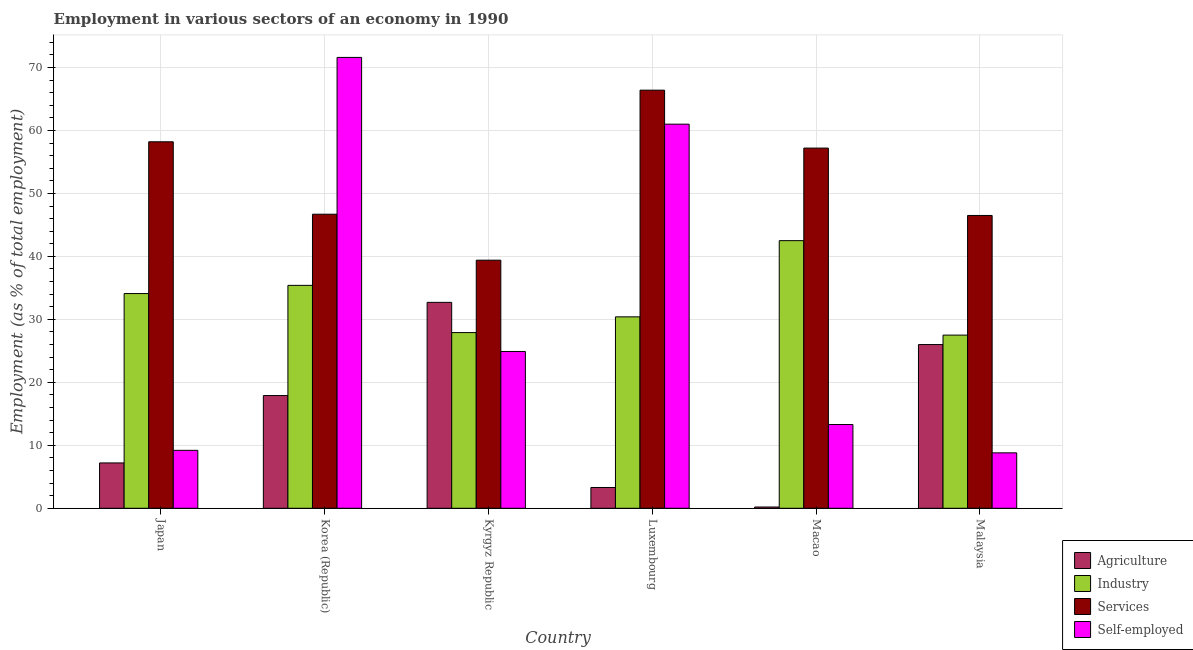How many different coloured bars are there?
Provide a short and direct response. 4. How many bars are there on the 6th tick from the right?
Offer a very short reply. 4. What is the label of the 6th group of bars from the left?
Offer a terse response. Malaysia. In how many cases, is the number of bars for a given country not equal to the number of legend labels?
Provide a succinct answer. 0. What is the percentage of workers in services in Kyrgyz Republic?
Keep it short and to the point. 39.4. Across all countries, what is the maximum percentage of self employed workers?
Make the answer very short. 71.6. Across all countries, what is the minimum percentage of self employed workers?
Your answer should be compact. 8.8. In which country was the percentage of workers in services maximum?
Your answer should be compact. Luxembourg. In which country was the percentage of workers in services minimum?
Give a very brief answer. Kyrgyz Republic. What is the total percentage of workers in industry in the graph?
Give a very brief answer. 197.8. What is the difference between the percentage of self employed workers in Macao and the percentage of workers in services in Kyrgyz Republic?
Your response must be concise. -26.1. What is the average percentage of workers in industry per country?
Make the answer very short. 32.97. What is the difference between the percentage of workers in industry and percentage of workers in agriculture in Malaysia?
Keep it short and to the point. 1.5. What is the ratio of the percentage of workers in services in Luxembourg to that in Malaysia?
Provide a succinct answer. 1.43. Is the difference between the percentage of workers in services in Korea (Republic) and Luxembourg greater than the difference between the percentage of self employed workers in Korea (Republic) and Luxembourg?
Offer a terse response. No. What is the difference between the highest and the second highest percentage of workers in industry?
Offer a very short reply. 7.1. What is the difference between the highest and the lowest percentage of workers in agriculture?
Offer a terse response. 32.5. In how many countries, is the percentage of self employed workers greater than the average percentage of self employed workers taken over all countries?
Offer a terse response. 2. What does the 1st bar from the left in Korea (Republic) represents?
Keep it short and to the point. Agriculture. What does the 2nd bar from the right in Japan represents?
Ensure brevity in your answer.  Services. Is it the case that in every country, the sum of the percentage of workers in agriculture and percentage of workers in industry is greater than the percentage of workers in services?
Your response must be concise. No. How many bars are there?
Give a very brief answer. 24. Are all the bars in the graph horizontal?
Give a very brief answer. No. Are the values on the major ticks of Y-axis written in scientific E-notation?
Keep it short and to the point. No. Does the graph contain grids?
Your answer should be compact. Yes. Where does the legend appear in the graph?
Your response must be concise. Bottom right. What is the title of the graph?
Your answer should be compact. Employment in various sectors of an economy in 1990. Does "Others" appear as one of the legend labels in the graph?
Offer a terse response. No. What is the label or title of the Y-axis?
Offer a very short reply. Employment (as % of total employment). What is the Employment (as % of total employment) in Agriculture in Japan?
Keep it short and to the point. 7.2. What is the Employment (as % of total employment) of Industry in Japan?
Your response must be concise. 34.1. What is the Employment (as % of total employment) of Services in Japan?
Make the answer very short. 58.2. What is the Employment (as % of total employment) of Self-employed in Japan?
Your answer should be compact. 9.2. What is the Employment (as % of total employment) in Agriculture in Korea (Republic)?
Ensure brevity in your answer.  17.9. What is the Employment (as % of total employment) of Industry in Korea (Republic)?
Offer a terse response. 35.4. What is the Employment (as % of total employment) in Services in Korea (Republic)?
Keep it short and to the point. 46.7. What is the Employment (as % of total employment) of Self-employed in Korea (Republic)?
Your response must be concise. 71.6. What is the Employment (as % of total employment) in Agriculture in Kyrgyz Republic?
Keep it short and to the point. 32.7. What is the Employment (as % of total employment) in Industry in Kyrgyz Republic?
Provide a short and direct response. 27.9. What is the Employment (as % of total employment) in Services in Kyrgyz Republic?
Your response must be concise. 39.4. What is the Employment (as % of total employment) in Self-employed in Kyrgyz Republic?
Your answer should be compact. 24.9. What is the Employment (as % of total employment) in Agriculture in Luxembourg?
Your response must be concise. 3.3. What is the Employment (as % of total employment) of Industry in Luxembourg?
Provide a succinct answer. 30.4. What is the Employment (as % of total employment) in Services in Luxembourg?
Keep it short and to the point. 66.4. What is the Employment (as % of total employment) in Agriculture in Macao?
Ensure brevity in your answer.  0.2. What is the Employment (as % of total employment) in Industry in Macao?
Provide a succinct answer. 42.5. What is the Employment (as % of total employment) of Services in Macao?
Offer a terse response. 57.2. What is the Employment (as % of total employment) of Self-employed in Macao?
Your answer should be very brief. 13.3. What is the Employment (as % of total employment) in Industry in Malaysia?
Your answer should be compact. 27.5. What is the Employment (as % of total employment) in Services in Malaysia?
Give a very brief answer. 46.5. What is the Employment (as % of total employment) in Self-employed in Malaysia?
Provide a succinct answer. 8.8. Across all countries, what is the maximum Employment (as % of total employment) in Agriculture?
Keep it short and to the point. 32.7. Across all countries, what is the maximum Employment (as % of total employment) of Industry?
Give a very brief answer. 42.5. Across all countries, what is the maximum Employment (as % of total employment) in Services?
Give a very brief answer. 66.4. Across all countries, what is the maximum Employment (as % of total employment) of Self-employed?
Offer a very short reply. 71.6. Across all countries, what is the minimum Employment (as % of total employment) of Agriculture?
Keep it short and to the point. 0.2. Across all countries, what is the minimum Employment (as % of total employment) in Services?
Your answer should be very brief. 39.4. Across all countries, what is the minimum Employment (as % of total employment) in Self-employed?
Your answer should be very brief. 8.8. What is the total Employment (as % of total employment) in Agriculture in the graph?
Keep it short and to the point. 87.3. What is the total Employment (as % of total employment) in Industry in the graph?
Make the answer very short. 197.8. What is the total Employment (as % of total employment) of Services in the graph?
Make the answer very short. 314.4. What is the total Employment (as % of total employment) in Self-employed in the graph?
Offer a very short reply. 188.8. What is the difference between the Employment (as % of total employment) of Agriculture in Japan and that in Korea (Republic)?
Offer a very short reply. -10.7. What is the difference between the Employment (as % of total employment) in Services in Japan and that in Korea (Republic)?
Your response must be concise. 11.5. What is the difference between the Employment (as % of total employment) of Self-employed in Japan and that in Korea (Republic)?
Ensure brevity in your answer.  -62.4. What is the difference between the Employment (as % of total employment) of Agriculture in Japan and that in Kyrgyz Republic?
Offer a terse response. -25.5. What is the difference between the Employment (as % of total employment) of Services in Japan and that in Kyrgyz Republic?
Offer a very short reply. 18.8. What is the difference between the Employment (as % of total employment) in Self-employed in Japan and that in Kyrgyz Republic?
Provide a short and direct response. -15.7. What is the difference between the Employment (as % of total employment) of Self-employed in Japan and that in Luxembourg?
Your answer should be compact. -51.8. What is the difference between the Employment (as % of total employment) in Industry in Japan and that in Macao?
Your response must be concise. -8.4. What is the difference between the Employment (as % of total employment) in Agriculture in Japan and that in Malaysia?
Provide a short and direct response. -18.8. What is the difference between the Employment (as % of total employment) of Agriculture in Korea (Republic) and that in Kyrgyz Republic?
Provide a short and direct response. -14.8. What is the difference between the Employment (as % of total employment) of Self-employed in Korea (Republic) and that in Kyrgyz Republic?
Make the answer very short. 46.7. What is the difference between the Employment (as % of total employment) in Agriculture in Korea (Republic) and that in Luxembourg?
Make the answer very short. 14.6. What is the difference between the Employment (as % of total employment) of Industry in Korea (Republic) and that in Luxembourg?
Give a very brief answer. 5. What is the difference between the Employment (as % of total employment) of Services in Korea (Republic) and that in Luxembourg?
Make the answer very short. -19.7. What is the difference between the Employment (as % of total employment) in Self-employed in Korea (Republic) and that in Macao?
Make the answer very short. 58.3. What is the difference between the Employment (as % of total employment) of Industry in Korea (Republic) and that in Malaysia?
Your answer should be compact. 7.9. What is the difference between the Employment (as % of total employment) of Services in Korea (Republic) and that in Malaysia?
Your answer should be very brief. 0.2. What is the difference between the Employment (as % of total employment) of Self-employed in Korea (Republic) and that in Malaysia?
Offer a very short reply. 62.8. What is the difference between the Employment (as % of total employment) of Agriculture in Kyrgyz Republic and that in Luxembourg?
Offer a terse response. 29.4. What is the difference between the Employment (as % of total employment) in Industry in Kyrgyz Republic and that in Luxembourg?
Your response must be concise. -2.5. What is the difference between the Employment (as % of total employment) of Self-employed in Kyrgyz Republic and that in Luxembourg?
Keep it short and to the point. -36.1. What is the difference between the Employment (as % of total employment) of Agriculture in Kyrgyz Republic and that in Macao?
Give a very brief answer. 32.5. What is the difference between the Employment (as % of total employment) in Industry in Kyrgyz Republic and that in Macao?
Give a very brief answer. -14.6. What is the difference between the Employment (as % of total employment) of Services in Kyrgyz Republic and that in Macao?
Your answer should be compact. -17.8. What is the difference between the Employment (as % of total employment) in Self-employed in Kyrgyz Republic and that in Macao?
Offer a terse response. 11.6. What is the difference between the Employment (as % of total employment) in Self-employed in Luxembourg and that in Macao?
Your response must be concise. 47.7. What is the difference between the Employment (as % of total employment) of Agriculture in Luxembourg and that in Malaysia?
Make the answer very short. -22.7. What is the difference between the Employment (as % of total employment) in Services in Luxembourg and that in Malaysia?
Make the answer very short. 19.9. What is the difference between the Employment (as % of total employment) in Self-employed in Luxembourg and that in Malaysia?
Give a very brief answer. 52.2. What is the difference between the Employment (as % of total employment) of Agriculture in Macao and that in Malaysia?
Your response must be concise. -25.8. What is the difference between the Employment (as % of total employment) in Industry in Macao and that in Malaysia?
Your answer should be very brief. 15. What is the difference between the Employment (as % of total employment) of Agriculture in Japan and the Employment (as % of total employment) of Industry in Korea (Republic)?
Provide a succinct answer. -28.2. What is the difference between the Employment (as % of total employment) of Agriculture in Japan and the Employment (as % of total employment) of Services in Korea (Republic)?
Your response must be concise. -39.5. What is the difference between the Employment (as % of total employment) of Agriculture in Japan and the Employment (as % of total employment) of Self-employed in Korea (Republic)?
Keep it short and to the point. -64.4. What is the difference between the Employment (as % of total employment) of Industry in Japan and the Employment (as % of total employment) of Self-employed in Korea (Republic)?
Offer a very short reply. -37.5. What is the difference between the Employment (as % of total employment) of Agriculture in Japan and the Employment (as % of total employment) of Industry in Kyrgyz Republic?
Keep it short and to the point. -20.7. What is the difference between the Employment (as % of total employment) of Agriculture in Japan and the Employment (as % of total employment) of Services in Kyrgyz Republic?
Give a very brief answer. -32.2. What is the difference between the Employment (as % of total employment) of Agriculture in Japan and the Employment (as % of total employment) of Self-employed in Kyrgyz Republic?
Make the answer very short. -17.7. What is the difference between the Employment (as % of total employment) in Industry in Japan and the Employment (as % of total employment) in Services in Kyrgyz Republic?
Offer a very short reply. -5.3. What is the difference between the Employment (as % of total employment) of Services in Japan and the Employment (as % of total employment) of Self-employed in Kyrgyz Republic?
Offer a terse response. 33.3. What is the difference between the Employment (as % of total employment) in Agriculture in Japan and the Employment (as % of total employment) in Industry in Luxembourg?
Give a very brief answer. -23.2. What is the difference between the Employment (as % of total employment) in Agriculture in Japan and the Employment (as % of total employment) in Services in Luxembourg?
Offer a terse response. -59.2. What is the difference between the Employment (as % of total employment) of Agriculture in Japan and the Employment (as % of total employment) of Self-employed in Luxembourg?
Offer a terse response. -53.8. What is the difference between the Employment (as % of total employment) of Industry in Japan and the Employment (as % of total employment) of Services in Luxembourg?
Your answer should be compact. -32.3. What is the difference between the Employment (as % of total employment) of Industry in Japan and the Employment (as % of total employment) of Self-employed in Luxembourg?
Your answer should be compact. -26.9. What is the difference between the Employment (as % of total employment) of Services in Japan and the Employment (as % of total employment) of Self-employed in Luxembourg?
Your answer should be very brief. -2.8. What is the difference between the Employment (as % of total employment) of Agriculture in Japan and the Employment (as % of total employment) of Industry in Macao?
Provide a short and direct response. -35.3. What is the difference between the Employment (as % of total employment) of Agriculture in Japan and the Employment (as % of total employment) of Services in Macao?
Your answer should be very brief. -50. What is the difference between the Employment (as % of total employment) in Agriculture in Japan and the Employment (as % of total employment) in Self-employed in Macao?
Keep it short and to the point. -6.1. What is the difference between the Employment (as % of total employment) in Industry in Japan and the Employment (as % of total employment) in Services in Macao?
Provide a succinct answer. -23.1. What is the difference between the Employment (as % of total employment) of Industry in Japan and the Employment (as % of total employment) of Self-employed in Macao?
Keep it short and to the point. 20.8. What is the difference between the Employment (as % of total employment) in Services in Japan and the Employment (as % of total employment) in Self-employed in Macao?
Ensure brevity in your answer.  44.9. What is the difference between the Employment (as % of total employment) of Agriculture in Japan and the Employment (as % of total employment) of Industry in Malaysia?
Provide a succinct answer. -20.3. What is the difference between the Employment (as % of total employment) of Agriculture in Japan and the Employment (as % of total employment) of Services in Malaysia?
Provide a succinct answer. -39.3. What is the difference between the Employment (as % of total employment) in Industry in Japan and the Employment (as % of total employment) in Self-employed in Malaysia?
Ensure brevity in your answer.  25.3. What is the difference between the Employment (as % of total employment) of Services in Japan and the Employment (as % of total employment) of Self-employed in Malaysia?
Make the answer very short. 49.4. What is the difference between the Employment (as % of total employment) in Agriculture in Korea (Republic) and the Employment (as % of total employment) in Services in Kyrgyz Republic?
Your answer should be very brief. -21.5. What is the difference between the Employment (as % of total employment) of Agriculture in Korea (Republic) and the Employment (as % of total employment) of Self-employed in Kyrgyz Republic?
Make the answer very short. -7. What is the difference between the Employment (as % of total employment) of Industry in Korea (Republic) and the Employment (as % of total employment) of Self-employed in Kyrgyz Republic?
Provide a succinct answer. 10.5. What is the difference between the Employment (as % of total employment) in Services in Korea (Republic) and the Employment (as % of total employment) in Self-employed in Kyrgyz Republic?
Offer a very short reply. 21.8. What is the difference between the Employment (as % of total employment) in Agriculture in Korea (Republic) and the Employment (as % of total employment) in Industry in Luxembourg?
Your response must be concise. -12.5. What is the difference between the Employment (as % of total employment) in Agriculture in Korea (Republic) and the Employment (as % of total employment) in Services in Luxembourg?
Make the answer very short. -48.5. What is the difference between the Employment (as % of total employment) in Agriculture in Korea (Republic) and the Employment (as % of total employment) in Self-employed in Luxembourg?
Ensure brevity in your answer.  -43.1. What is the difference between the Employment (as % of total employment) in Industry in Korea (Republic) and the Employment (as % of total employment) in Services in Luxembourg?
Offer a terse response. -31. What is the difference between the Employment (as % of total employment) in Industry in Korea (Republic) and the Employment (as % of total employment) in Self-employed in Luxembourg?
Make the answer very short. -25.6. What is the difference between the Employment (as % of total employment) of Services in Korea (Republic) and the Employment (as % of total employment) of Self-employed in Luxembourg?
Your answer should be compact. -14.3. What is the difference between the Employment (as % of total employment) of Agriculture in Korea (Republic) and the Employment (as % of total employment) of Industry in Macao?
Your answer should be compact. -24.6. What is the difference between the Employment (as % of total employment) of Agriculture in Korea (Republic) and the Employment (as % of total employment) of Services in Macao?
Keep it short and to the point. -39.3. What is the difference between the Employment (as % of total employment) in Agriculture in Korea (Republic) and the Employment (as % of total employment) in Self-employed in Macao?
Give a very brief answer. 4.6. What is the difference between the Employment (as % of total employment) of Industry in Korea (Republic) and the Employment (as % of total employment) of Services in Macao?
Offer a very short reply. -21.8. What is the difference between the Employment (as % of total employment) of Industry in Korea (Republic) and the Employment (as % of total employment) of Self-employed in Macao?
Provide a succinct answer. 22.1. What is the difference between the Employment (as % of total employment) in Services in Korea (Republic) and the Employment (as % of total employment) in Self-employed in Macao?
Make the answer very short. 33.4. What is the difference between the Employment (as % of total employment) of Agriculture in Korea (Republic) and the Employment (as % of total employment) of Services in Malaysia?
Your answer should be very brief. -28.6. What is the difference between the Employment (as % of total employment) in Agriculture in Korea (Republic) and the Employment (as % of total employment) in Self-employed in Malaysia?
Your response must be concise. 9.1. What is the difference between the Employment (as % of total employment) of Industry in Korea (Republic) and the Employment (as % of total employment) of Services in Malaysia?
Your response must be concise. -11.1. What is the difference between the Employment (as % of total employment) in Industry in Korea (Republic) and the Employment (as % of total employment) in Self-employed in Malaysia?
Ensure brevity in your answer.  26.6. What is the difference between the Employment (as % of total employment) of Services in Korea (Republic) and the Employment (as % of total employment) of Self-employed in Malaysia?
Keep it short and to the point. 37.9. What is the difference between the Employment (as % of total employment) in Agriculture in Kyrgyz Republic and the Employment (as % of total employment) in Services in Luxembourg?
Make the answer very short. -33.7. What is the difference between the Employment (as % of total employment) of Agriculture in Kyrgyz Republic and the Employment (as % of total employment) of Self-employed in Luxembourg?
Your response must be concise. -28.3. What is the difference between the Employment (as % of total employment) of Industry in Kyrgyz Republic and the Employment (as % of total employment) of Services in Luxembourg?
Provide a succinct answer. -38.5. What is the difference between the Employment (as % of total employment) of Industry in Kyrgyz Republic and the Employment (as % of total employment) of Self-employed in Luxembourg?
Provide a short and direct response. -33.1. What is the difference between the Employment (as % of total employment) in Services in Kyrgyz Republic and the Employment (as % of total employment) in Self-employed in Luxembourg?
Your response must be concise. -21.6. What is the difference between the Employment (as % of total employment) of Agriculture in Kyrgyz Republic and the Employment (as % of total employment) of Industry in Macao?
Offer a terse response. -9.8. What is the difference between the Employment (as % of total employment) in Agriculture in Kyrgyz Republic and the Employment (as % of total employment) in Services in Macao?
Offer a very short reply. -24.5. What is the difference between the Employment (as % of total employment) of Industry in Kyrgyz Republic and the Employment (as % of total employment) of Services in Macao?
Keep it short and to the point. -29.3. What is the difference between the Employment (as % of total employment) in Industry in Kyrgyz Republic and the Employment (as % of total employment) in Self-employed in Macao?
Give a very brief answer. 14.6. What is the difference between the Employment (as % of total employment) of Services in Kyrgyz Republic and the Employment (as % of total employment) of Self-employed in Macao?
Offer a terse response. 26.1. What is the difference between the Employment (as % of total employment) of Agriculture in Kyrgyz Republic and the Employment (as % of total employment) of Services in Malaysia?
Keep it short and to the point. -13.8. What is the difference between the Employment (as % of total employment) in Agriculture in Kyrgyz Republic and the Employment (as % of total employment) in Self-employed in Malaysia?
Offer a terse response. 23.9. What is the difference between the Employment (as % of total employment) in Industry in Kyrgyz Republic and the Employment (as % of total employment) in Services in Malaysia?
Your answer should be compact. -18.6. What is the difference between the Employment (as % of total employment) in Industry in Kyrgyz Republic and the Employment (as % of total employment) in Self-employed in Malaysia?
Your answer should be very brief. 19.1. What is the difference between the Employment (as % of total employment) of Services in Kyrgyz Republic and the Employment (as % of total employment) of Self-employed in Malaysia?
Ensure brevity in your answer.  30.6. What is the difference between the Employment (as % of total employment) of Agriculture in Luxembourg and the Employment (as % of total employment) of Industry in Macao?
Provide a short and direct response. -39.2. What is the difference between the Employment (as % of total employment) of Agriculture in Luxembourg and the Employment (as % of total employment) of Services in Macao?
Offer a very short reply. -53.9. What is the difference between the Employment (as % of total employment) of Agriculture in Luxembourg and the Employment (as % of total employment) of Self-employed in Macao?
Keep it short and to the point. -10. What is the difference between the Employment (as % of total employment) in Industry in Luxembourg and the Employment (as % of total employment) in Services in Macao?
Your answer should be very brief. -26.8. What is the difference between the Employment (as % of total employment) of Services in Luxembourg and the Employment (as % of total employment) of Self-employed in Macao?
Your answer should be compact. 53.1. What is the difference between the Employment (as % of total employment) of Agriculture in Luxembourg and the Employment (as % of total employment) of Industry in Malaysia?
Provide a succinct answer. -24.2. What is the difference between the Employment (as % of total employment) of Agriculture in Luxembourg and the Employment (as % of total employment) of Services in Malaysia?
Provide a short and direct response. -43.2. What is the difference between the Employment (as % of total employment) of Industry in Luxembourg and the Employment (as % of total employment) of Services in Malaysia?
Offer a terse response. -16.1. What is the difference between the Employment (as % of total employment) of Industry in Luxembourg and the Employment (as % of total employment) of Self-employed in Malaysia?
Give a very brief answer. 21.6. What is the difference between the Employment (as % of total employment) of Services in Luxembourg and the Employment (as % of total employment) of Self-employed in Malaysia?
Ensure brevity in your answer.  57.6. What is the difference between the Employment (as % of total employment) of Agriculture in Macao and the Employment (as % of total employment) of Industry in Malaysia?
Your answer should be very brief. -27.3. What is the difference between the Employment (as % of total employment) of Agriculture in Macao and the Employment (as % of total employment) of Services in Malaysia?
Offer a terse response. -46.3. What is the difference between the Employment (as % of total employment) in Industry in Macao and the Employment (as % of total employment) in Services in Malaysia?
Make the answer very short. -4. What is the difference between the Employment (as % of total employment) of Industry in Macao and the Employment (as % of total employment) of Self-employed in Malaysia?
Provide a succinct answer. 33.7. What is the difference between the Employment (as % of total employment) of Services in Macao and the Employment (as % of total employment) of Self-employed in Malaysia?
Your answer should be very brief. 48.4. What is the average Employment (as % of total employment) in Agriculture per country?
Provide a short and direct response. 14.55. What is the average Employment (as % of total employment) in Industry per country?
Offer a very short reply. 32.97. What is the average Employment (as % of total employment) of Services per country?
Provide a succinct answer. 52.4. What is the average Employment (as % of total employment) of Self-employed per country?
Keep it short and to the point. 31.47. What is the difference between the Employment (as % of total employment) in Agriculture and Employment (as % of total employment) in Industry in Japan?
Offer a terse response. -26.9. What is the difference between the Employment (as % of total employment) in Agriculture and Employment (as % of total employment) in Services in Japan?
Your answer should be compact. -51. What is the difference between the Employment (as % of total employment) of Industry and Employment (as % of total employment) of Services in Japan?
Give a very brief answer. -24.1. What is the difference between the Employment (as % of total employment) of Industry and Employment (as % of total employment) of Self-employed in Japan?
Provide a succinct answer. 24.9. What is the difference between the Employment (as % of total employment) in Agriculture and Employment (as % of total employment) in Industry in Korea (Republic)?
Give a very brief answer. -17.5. What is the difference between the Employment (as % of total employment) in Agriculture and Employment (as % of total employment) in Services in Korea (Republic)?
Offer a terse response. -28.8. What is the difference between the Employment (as % of total employment) of Agriculture and Employment (as % of total employment) of Self-employed in Korea (Republic)?
Keep it short and to the point. -53.7. What is the difference between the Employment (as % of total employment) of Industry and Employment (as % of total employment) of Self-employed in Korea (Republic)?
Provide a short and direct response. -36.2. What is the difference between the Employment (as % of total employment) of Services and Employment (as % of total employment) of Self-employed in Korea (Republic)?
Ensure brevity in your answer.  -24.9. What is the difference between the Employment (as % of total employment) of Agriculture and Employment (as % of total employment) of Services in Kyrgyz Republic?
Provide a short and direct response. -6.7. What is the difference between the Employment (as % of total employment) of Agriculture and Employment (as % of total employment) of Self-employed in Kyrgyz Republic?
Provide a succinct answer. 7.8. What is the difference between the Employment (as % of total employment) in Industry and Employment (as % of total employment) in Services in Kyrgyz Republic?
Ensure brevity in your answer.  -11.5. What is the difference between the Employment (as % of total employment) in Industry and Employment (as % of total employment) in Self-employed in Kyrgyz Republic?
Your response must be concise. 3. What is the difference between the Employment (as % of total employment) in Services and Employment (as % of total employment) in Self-employed in Kyrgyz Republic?
Make the answer very short. 14.5. What is the difference between the Employment (as % of total employment) of Agriculture and Employment (as % of total employment) of Industry in Luxembourg?
Your answer should be very brief. -27.1. What is the difference between the Employment (as % of total employment) of Agriculture and Employment (as % of total employment) of Services in Luxembourg?
Provide a short and direct response. -63.1. What is the difference between the Employment (as % of total employment) in Agriculture and Employment (as % of total employment) in Self-employed in Luxembourg?
Make the answer very short. -57.7. What is the difference between the Employment (as % of total employment) in Industry and Employment (as % of total employment) in Services in Luxembourg?
Offer a very short reply. -36. What is the difference between the Employment (as % of total employment) in Industry and Employment (as % of total employment) in Self-employed in Luxembourg?
Your answer should be compact. -30.6. What is the difference between the Employment (as % of total employment) of Agriculture and Employment (as % of total employment) of Industry in Macao?
Provide a succinct answer. -42.3. What is the difference between the Employment (as % of total employment) of Agriculture and Employment (as % of total employment) of Services in Macao?
Your answer should be compact. -57. What is the difference between the Employment (as % of total employment) in Industry and Employment (as % of total employment) in Services in Macao?
Give a very brief answer. -14.7. What is the difference between the Employment (as % of total employment) in Industry and Employment (as % of total employment) in Self-employed in Macao?
Your response must be concise. 29.2. What is the difference between the Employment (as % of total employment) in Services and Employment (as % of total employment) in Self-employed in Macao?
Provide a short and direct response. 43.9. What is the difference between the Employment (as % of total employment) in Agriculture and Employment (as % of total employment) in Industry in Malaysia?
Your response must be concise. -1.5. What is the difference between the Employment (as % of total employment) in Agriculture and Employment (as % of total employment) in Services in Malaysia?
Give a very brief answer. -20.5. What is the difference between the Employment (as % of total employment) of Agriculture and Employment (as % of total employment) of Self-employed in Malaysia?
Give a very brief answer. 17.2. What is the difference between the Employment (as % of total employment) in Services and Employment (as % of total employment) in Self-employed in Malaysia?
Your answer should be compact. 37.7. What is the ratio of the Employment (as % of total employment) in Agriculture in Japan to that in Korea (Republic)?
Keep it short and to the point. 0.4. What is the ratio of the Employment (as % of total employment) of Industry in Japan to that in Korea (Republic)?
Keep it short and to the point. 0.96. What is the ratio of the Employment (as % of total employment) in Services in Japan to that in Korea (Republic)?
Your answer should be very brief. 1.25. What is the ratio of the Employment (as % of total employment) in Self-employed in Japan to that in Korea (Republic)?
Keep it short and to the point. 0.13. What is the ratio of the Employment (as % of total employment) of Agriculture in Japan to that in Kyrgyz Republic?
Keep it short and to the point. 0.22. What is the ratio of the Employment (as % of total employment) of Industry in Japan to that in Kyrgyz Republic?
Your answer should be compact. 1.22. What is the ratio of the Employment (as % of total employment) in Services in Japan to that in Kyrgyz Republic?
Offer a terse response. 1.48. What is the ratio of the Employment (as % of total employment) of Self-employed in Japan to that in Kyrgyz Republic?
Offer a very short reply. 0.37. What is the ratio of the Employment (as % of total employment) in Agriculture in Japan to that in Luxembourg?
Give a very brief answer. 2.18. What is the ratio of the Employment (as % of total employment) of Industry in Japan to that in Luxembourg?
Your answer should be compact. 1.12. What is the ratio of the Employment (as % of total employment) of Services in Japan to that in Luxembourg?
Offer a very short reply. 0.88. What is the ratio of the Employment (as % of total employment) in Self-employed in Japan to that in Luxembourg?
Keep it short and to the point. 0.15. What is the ratio of the Employment (as % of total employment) in Industry in Japan to that in Macao?
Keep it short and to the point. 0.8. What is the ratio of the Employment (as % of total employment) in Services in Japan to that in Macao?
Your answer should be compact. 1.02. What is the ratio of the Employment (as % of total employment) in Self-employed in Japan to that in Macao?
Your answer should be very brief. 0.69. What is the ratio of the Employment (as % of total employment) in Agriculture in Japan to that in Malaysia?
Give a very brief answer. 0.28. What is the ratio of the Employment (as % of total employment) of Industry in Japan to that in Malaysia?
Make the answer very short. 1.24. What is the ratio of the Employment (as % of total employment) of Services in Japan to that in Malaysia?
Offer a terse response. 1.25. What is the ratio of the Employment (as % of total employment) in Self-employed in Japan to that in Malaysia?
Your response must be concise. 1.05. What is the ratio of the Employment (as % of total employment) of Agriculture in Korea (Republic) to that in Kyrgyz Republic?
Make the answer very short. 0.55. What is the ratio of the Employment (as % of total employment) in Industry in Korea (Republic) to that in Kyrgyz Republic?
Your answer should be compact. 1.27. What is the ratio of the Employment (as % of total employment) of Services in Korea (Republic) to that in Kyrgyz Republic?
Your answer should be compact. 1.19. What is the ratio of the Employment (as % of total employment) of Self-employed in Korea (Republic) to that in Kyrgyz Republic?
Keep it short and to the point. 2.88. What is the ratio of the Employment (as % of total employment) of Agriculture in Korea (Republic) to that in Luxembourg?
Your answer should be very brief. 5.42. What is the ratio of the Employment (as % of total employment) in Industry in Korea (Republic) to that in Luxembourg?
Provide a succinct answer. 1.16. What is the ratio of the Employment (as % of total employment) in Services in Korea (Republic) to that in Luxembourg?
Ensure brevity in your answer.  0.7. What is the ratio of the Employment (as % of total employment) of Self-employed in Korea (Republic) to that in Luxembourg?
Keep it short and to the point. 1.17. What is the ratio of the Employment (as % of total employment) in Agriculture in Korea (Republic) to that in Macao?
Ensure brevity in your answer.  89.5. What is the ratio of the Employment (as % of total employment) in Industry in Korea (Republic) to that in Macao?
Provide a succinct answer. 0.83. What is the ratio of the Employment (as % of total employment) of Services in Korea (Republic) to that in Macao?
Provide a short and direct response. 0.82. What is the ratio of the Employment (as % of total employment) of Self-employed in Korea (Republic) to that in Macao?
Keep it short and to the point. 5.38. What is the ratio of the Employment (as % of total employment) of Agriculture in Korea (Republic) to that in Malaysia?
Provide a short and direct response. 0.69. What is the ratio of the Employment (as % of total employment) of Industry in Korea (Republic) to that in Malaysia?
Give a very brief answer. 1.29. What is the ratio of the Employment (as % of total employment) in Services in Korea (Republic) to that in Malaysia?
Provide a succinct answer. 1. What is the ratio of the Employment (as % of total employment) in Self-employed in Korea (Republic) to that in Malaysia?
Give a very brief answer. 8.14. What is the ratio of the Employment (as % of total employment) in Agriculture in Kyrgyz Republic to that in Luxembourg?
Provide a succinct answer. 9.91. What is the ratio of the Employment (as % of total employment) of Industry in Kyrgyz Republic to that in Luxembourg?
Provide a succinct answer. 0.92. What is the ratio of the Employment (as % of total employment) of Services in Kyrgyz Republic to that in Luxembourg?
Offer a terse response. 0.59. What is the ratio of the Employment (as % of total employment) of Self-employed in Kyrgyz Republic to that in Luxembourg?
Provide a succinct answer. 0.41. What is the ratio of the Employment (as % of total employment) of Agriculture in Kyrgyz Republic to that in Macao?
Provide a short and direct response. 163.5. What is the ratio of the Employment (as % of total employment) of Industry in Kyrgyz Republic to that in Macao?
Your answer should be very brief. 0.66. What is the ratio of the Employment (as % of total employment) of Services in Kyrgyz Republic to that in Macao?
Provide a short and direct response. 0.69. What is the ratio of the Employment (as % of total employment) of Self-employed in Kyrgyz Republic to that in Macao?
Offer a terse response. 1.87. What is the ratio of the Employment (as % of total employment) of Agriculture in Kyrgyz Republic to that in Malaysia?
Offer a very short reply. 1.26. What is the ratio of the Employment (as % of total employment) of Industry in Kyrgyz Republic to that in Malaysia?
Give a very brief answer. 1.01. What is the ratio of the Employment (as % of total employment) of Services in Kyrgyz Republic to that in Malaysia?
Keep it short and to the point. 0.85. What is the ratio of the Employment (as % of total employment) in Self-employed in Kyrgyz Republic to that in Malaysia?
Provide a short and direct response. 2.83. What is the ratio of the Employment (as % of total employment) in Industry in Luxembourg to that in Macao?
Provide a succinct answer. 0.72. What is the ratio of the Employment (as % of total employment) of Services in Luxembourg to that in Macao?
Offer a very short reply. 1.16. What is the ratio of the Employment (as % of total employment) of Self-employed in Luxembourg to that in Macao?
Ensure brevity in your answer.  4.59. What is the ratio of the Employment (as % of total employment) of Agriculture in Luxembourg to that in Malaysia?
Keep it short and to the point. 0.13. What is the ratio of the Employment (as % of total employment) of Industry in Luxembourg to that in Malaysia?
Keep it short and to the point. 1.11. What is the ratio of the Employment (as % of total employment) of Services in Luxembourg to that in Malaysia?
Your response must be concise. 1.43. What is the ratio of the Employment (as % of total employment) of Self-employed in Luxembourg to that in Malaysia?
Make the answer very short. 6.93. What is the ratio of the Employment (as % of total employment) of Agriculture in Macao to that in Malaysia?
Offer a terse response. 0.01. What is the ratio of the Employment (as % of total employment) in Industry in Macao to that in Malaysia?
Keep it short and to the point. 1.55. What is the ratio of the Employment (as % of total employment) of Services in Macao to that in Malaysia?
Ensure brevity in your answer.  1.23. What is the ratio of the Employment (as % of total employment) in Self-employed in Macao to that in Malaysia?
Make the answer very short. 1.51. What is the difference between the highest and the second highest Employment (as % of total employment) in Agriculture?
Ensure brevity in your answer.  6.7. What is the difference between the highest and the second highest Employment (as % of total employment) in Industry?
Your response must be concise. 7.1. What is the difference between the highest and the lowest Employment (as % of total employment) of Agriculture?
Provide a short and direct response. 32.5. What is the difference between the highest and the lowest Employment (as % of total employment) of Self-employed?
Provide a succinct answer. 62.8. 